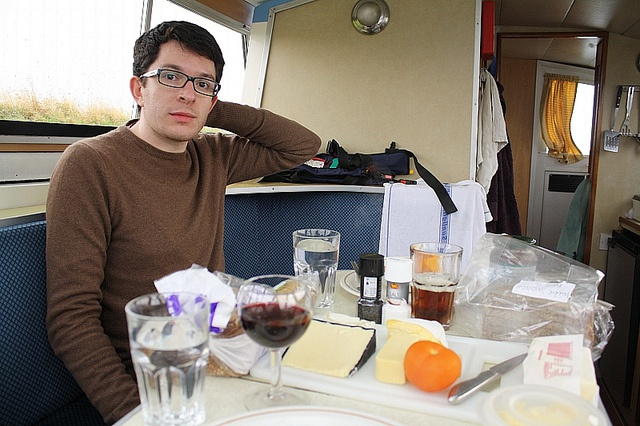Describe the objects in this image and their specific colors. I can see dining table in white, lightgray, darkgray, beige, and gray tones, people in white, maroon, black, and gray tones, couch in white, black, lavender, navy, and gray tones, cup in white, lightgray, darkgray, and gray tones, and wine glass in white, lightgray, darkgray, and black tones in this image. 